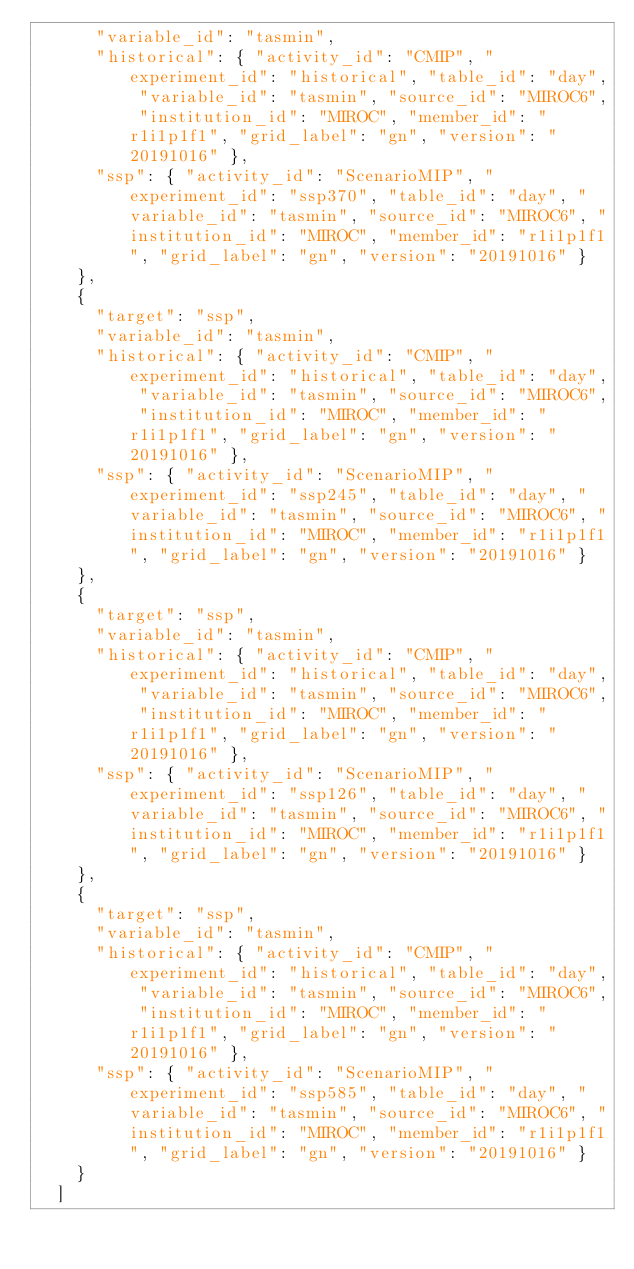<code> <loc_0><loc_0><loc_500><loc_500><_YAML_>      "variable_id": "tasmin",
      "historical": { "activity_id": "CMIP", "experiment_id": "historical", "table_id": "day", "variable_id": "tasmin", "source_id": "MIROC6", "institution_id": "MIROC", "member_id": "r1i1p1f1", "grid_label": "gn", "version": "20191016" },
      "ssp": { "activity_id": "ScenarioMIP", "experiment_id": "ssp370", "table_id": "day", "variable_id": "tasmin", "source_id": "MIROC6", "institution_id": "MIROC", "member_id": "r1i1p1f1", "grid_label": "gn", "version": "20191016" }
    },
    {
      "target": "ssp",
      "variable_id": "tasmin",
      "historical": { "activity_id": "CMIP", "experiment_id": "historical", "table_id": "day", "variable_id": "tasmin", "source_id": "MIROC6", "institution_id": "MIROC", "member_id": "r1i1p1f1", "grid_label": "gn", "version": "20191016" },
      "ssp": { "activity_id": "ScenarioMIP", "experiment_id": "ssp245", "table_id": "day", "variable_id": "tasmin", "source_id": "MIROC6", "institution_id": "MIROC", "member_id": "r1i1p1f1", "grid_label": "gn", "version": "20191016" }
    },
    {
      "target": "ssp",
      "variable_id": "tasmin",
      "historical": { "activity_id": "CMIP", "experiment_id": "historical", "table_id": "day", "variable_id": "tasmin", "source_id": "MIROC6", "institution_id": "MIROC", "member_id": "r1i1p1f1", "grid_label": "gn", "version": "20191016" },
      "ssp": { "activity_id": "ScenarioMIP", "experiment_id": "ssp126", "table_id": "day", "variable_id": "tasmin", "source_id": "MIROC6", "institution_id": "MIROC", "member_id": "r1i1p1f1", "grid_label": "gn", "version": "20191016" }
    },
    {
      "target": "ssp",
      "variable_id": "tasmin",
      "historical": { "activity_id": "CMIP", "experiment_id": "historical", "table_id": "day", "variable_id": "tasmin", "source_id": "MIROC6", "institution_id": "MIROC", "member_id": "r1i1p1f1", "grid_label": "gn", "version": "20191016" },
      "ssp": { "activity_id": "ScenarioMIP", "experiment_id": "ssp585", "table_id": "day", "variable_id": "tasmin", "source_id": "MIROC6", "institution_id": "MIROC", "member_id": "r1i1p1f1", "grid_label": "gn", "version": "20191016" }
    }
  ]
</code> 